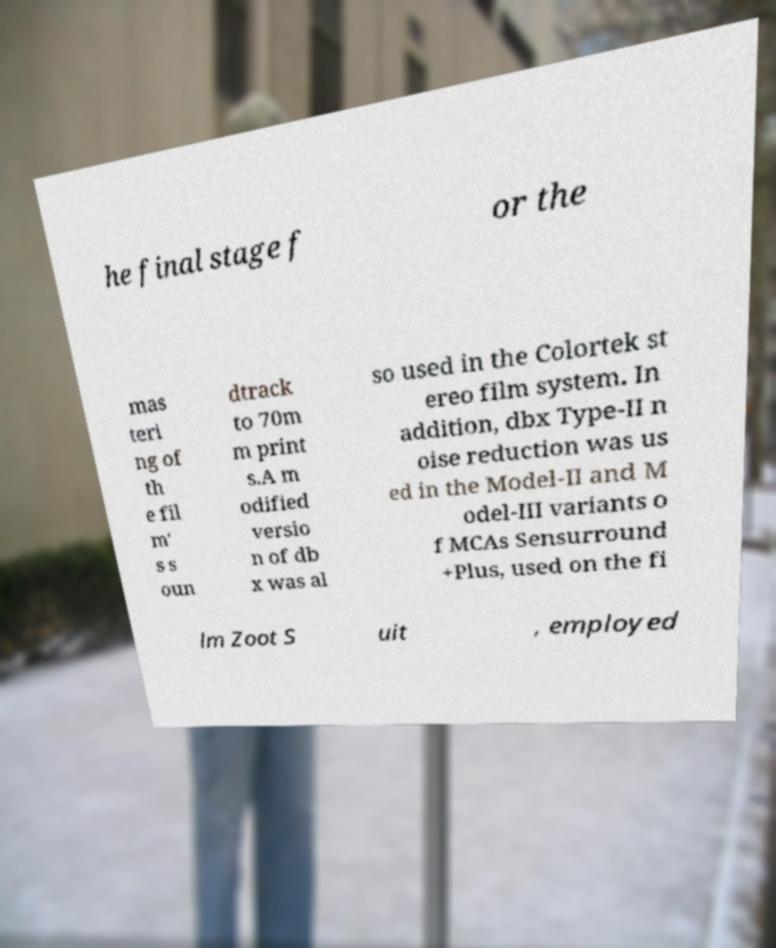For documentation purposes, I need the text within this image transcribed. Could you provide that? he final stage f or the mas teri ng of th e fil m' s s oun dtrack to 70m m print s.A m odified versio n of db x was al so used in the Colortek st ereo film system. In addition, dbx Type-II n oise reduction was us ed in the Model-II and M odel-III variants o f MCAs Sensurround +Plus, used on the fi lm Zoot S uit , employed 